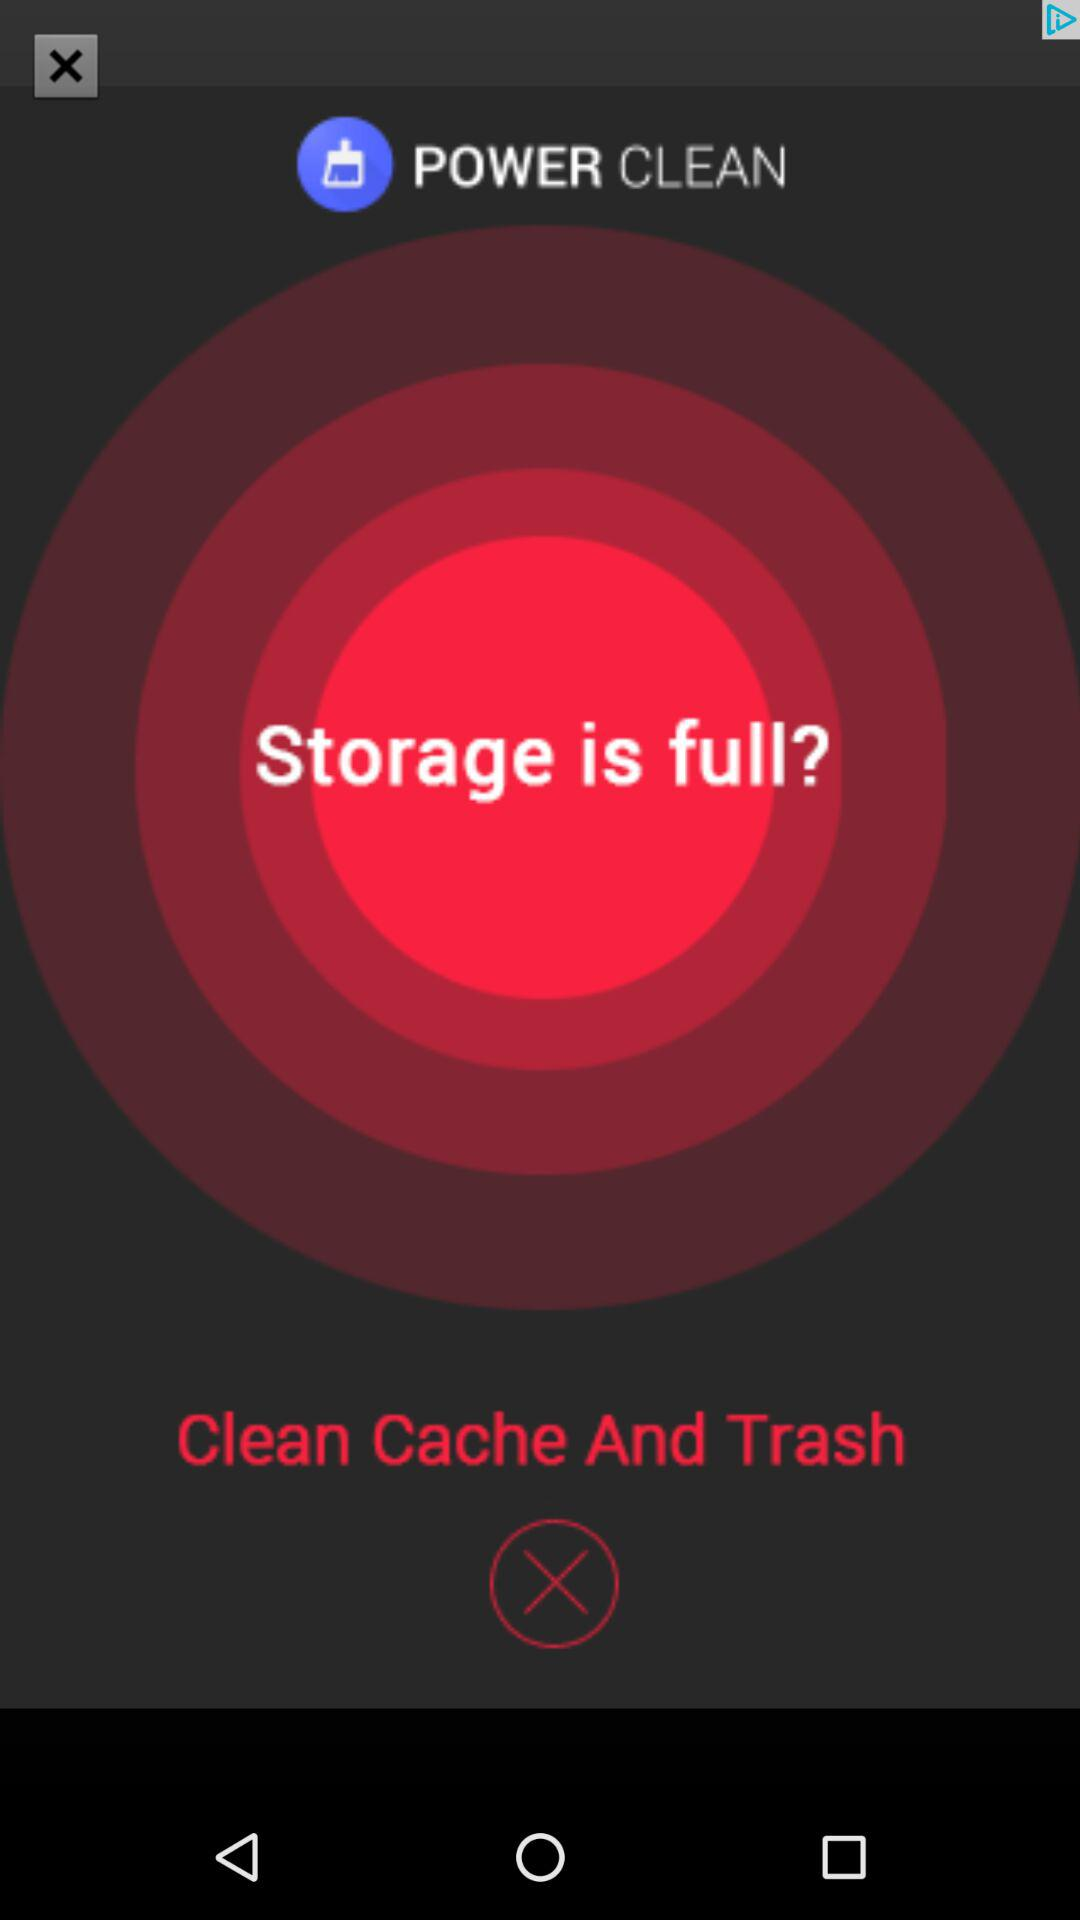What is the version of this application?
When the provided information is insufficient, respond with <no answer>. <no answer> 